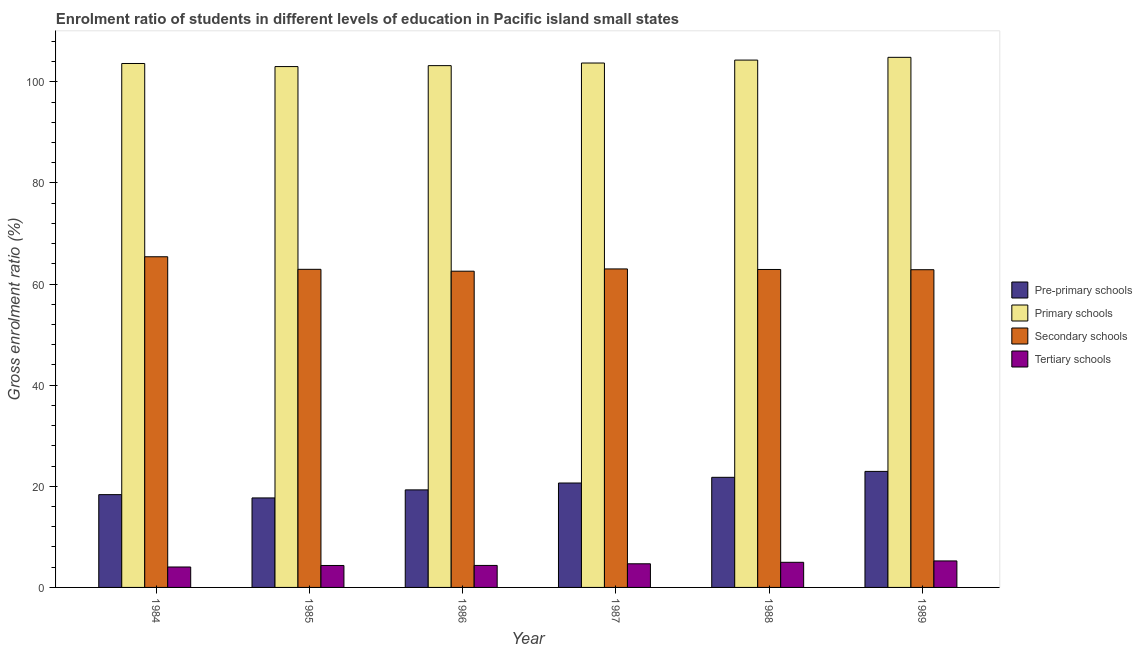How many different coloured bars are there?
Make the answer very short. 4. How many groups of bars are there?
Keep it short and to the point. 6. Are the number of bars per tick equal to the number of legend labels?
Offer a terse response. Yes. Are the number of bars on each tick of the X-axis equal?
Provide a succinct answer. Yes. How many bars are there on the 1st tick from the left?
Give a very brief answer. 4. How many bars are there on the 3rd tick from the right?
Provide a succinct answer. 4. What is the label of the 2nd group of bars from the left?
Offer a terse response. 1985. In how many cases, is the number of bars for a given year not equal to the number of legend labels?
Offer a terse response. 0. What is the gross enrolment ratio in secondary schools in 1988?
Your answer should be compact. 62.89. Across all years, what is the maximum gross enrolment ratio in pre-primary schools?
Your response must be concise. 22.95. Across all years, what is the minimum gross enrolment ratio in tertiary schools?
Ensure brevity in your answer.  4.04. In which year was the gross enrolment ratio in primary schools minimum?
Your response must be concise. 1985. What is the total gross enrolment ratio in tertiary schools in the graph?
Provide a short and direct response. 27.62. What is the difference between the gross enrolment ratio in tertiary schools in 1984 and that in 1986?
Offer a very short reply. -0.31. What is the difference between the gross enrolment ratio in secondary schools in 1989 and the gross enrolment ratio in tertiary schools in 1987?
Your response must be concise. -0.16. What is the average gross enrolment ratio in tertiary schools per year?
Give a very brief answer. 4.6. In the year 1987, what is the difference between the gross enrolment ratio in pre-primary schools and gross enrolment ratio in tertiary schools?
Offer a terse response. 0. What is the ratio of the gross enrolment ratio in pre-primary schools in 1984 to that in 1989?
Your answer should be compact. 0.8. Is the difference between the gross enrolment ratio in primary schools in 1987 and 1988 greater than the difference between the gross enrolment ratio in tertiary schools in 1987 and 1988?
Make the answer very short. No. What is the difference between the highest and the second highest gross enrolment ratio in secondary schools?
Make the answer very short. 2.41. What is the difference between the highest and the lowest gross enrolment ratio in primary schools?
Your answer should be very brief. 1.83. In how many years, is the gross enrolment ratio in primary schools greater than the average gross enrolment ratio in primary schools taken over all years?
Ensure brevity in your answer.  2. Is the sum of the gross enrolment ratio in secondary schools in 1984 and 1987 greater than the maximum gross enrolment ratio in tertiary schools across all years?
Provide a succinct answer. Yes. Is it the case that in every year, the sum of the gross enrolment ratio in secondary schools and gross enrolment ratio in tertiary schools is greater than the sum of gross enrolment ratio in pre-primary schools and gross enrolment ratio in primary schools?
Make the answer very short. No. What does the 1st bar from the left in 1986 represents?
Ensure brevity in your answer.  Pre-primary schools. What does the 1st bar from the right in 1984 represents?
Ensure brevity in your answer.  Tertiary schools. How many bars are there?
Your answer should be very brief. 24. Are the values on the major ticks of Y-axis written in scientific E-notation?
Keep it short and to the point. No. Does the graph contain grids?
Offer a very short reply. No. How many legend labels are there?
Give a very brief answer. 4. What is the title of the graph?
Make the answer very short. Enrolment ratio of students in different levels of education in Pacific island small states. What is the label or title of the X-axis?
Ensure brevity in your answer.  Year. What is the label or title of the Y-axis?
Your answer should be very brief. Gross enrolment ratio (%). What is the Gross enrolment ratio (%) in Pre-primary schools in 1984?
Ensure brevity in your answer.  18.35. What is the Gross enrolment ratio (%) in Primary schools in 1984?
Give a very brief answer. 103.63. What is the Gross enrolment ratio (%) in Secondary schools in 1984?
Your response must be concise. 65.4. What is the Gross enrolment ratio (%) in Tertiary schools in 1984?
Keep it short and to the point. 4.04. What is the Gross enrolment ratio (%) in Pre-primary schools in 1985?
Ensure brevity in your answer.  17.7. What is the Gross enrolment ratio (%) in Primary schools in 1985?
Provide a short and direct response. 103.02. What is the Gross enrolment ratio (%) of Secondary schools in 1985?
Make the answer very short. 62.92. What is the Gross enrolment ratio (%) of Tertiary schools in 1985?
Offer a very short reply. 4.34. What is the Gross enrolment ratio (%) in Pre-primary schools in 1986?
Your response must be concise. 19.29. What is the Gross enrolment ratio (%) of Primary schools in 1986?
Your response must be concise. 103.21. What is the Gross enrolment ratio (%) in Secondary schools in 1986?
Provide a succinct answer. 62.55. What is the Gross enrolment ratio (%) in Tertiary schools in 1986?
Provide a short and direct response. 4.35. What is the Gross enrolment ratio (%) in Pre-primary schools in 1987?
Provide a succinct answer. 20.65. What is the Gross enrolment ratio (%) in Primary schools in 1987?
Ensure brevity in your answer.  103.72. What is the Gross enrolment ratio (%) of Secondary schools in 1987?
Keep it short and to the point. 63. What is the Gross enrolment ratio (%) in Tertiary schools in 1987?
Provide a short and direct response. 4.67. What is the Gross enrolment ratio (%) in Pre-primary schools in 1988?
Provide a short and direct response. 21.78. What is the Gross enrolment ratio (%) in Primary schools in 1988?
Provide a short and direct response. 104.3. What is the Gross enrolment ratio (%) in Secondary schools in 1988?
Give a very brief answer. 62.89. What is the Gross enrolment ratio (%) of Tertiary schools in 1988?
Ensure brevity in your answer.  4.97. What is the Gross enrolment ratio (%) in Pre-primary schools in 1989?
Offer a very short reply. 22.95. What is the Gross enrolment ratio (%) of Primary schools in 1989?
Provide a short and direct response. 104.85. What is the Gross enrolment ratio (%) in Secondary schools in 1989?
Your answer should be compact. 62.84. What is the Gross enrolment ratio (%) of Tertiary schools in 1989?
Make the answer very short. 5.24. Across all years, what is the maximum Gross enrolment ratio (%) in Pre-primary schools?
Ensure brevity in your answer.  22.95. Across all years, what is the maximum Gross enrolment ratio (%) in Primary schools?
Give a very brief answer. 104.85. Across all years, what is the maximum Gross enrolment ratio (%) of Secondary schools?
Offer a terse response. 65.4. Across all years, what is the maximum Gross enrolment ratio (%) of Tertiary schools?
Your answer should be very brief. 5.24. Across all years, what is the minimum Gross enrolment ratio (%) of Pre-primary schools?
Keep it short and to the point. 17.7. Across all years, what is the minimum Gross enrolment ratio (%) of Primary schools?
Keep it short and to the point. 103.02. Across all years, what is the minimum Gross enrolment ratio (%) in Secondary schools?
Keep it short and to the point. 62.55. Across all years, what is the minimum Gross enrolment ratio (%) of Tertiary schools?
Keep it short and to the point. 4.04. What is the total Gross enrolment ratio (%) in Pre-primary schools in the graph?
Provide a succinct answer. 120.73. What is the total Gross enrolment ratio (%) of Primary schools in the graph?
Ensure brevity in your answer.  622.73. What is the total Gross enrolment ratio (%) in Secondary schools in the graph?
Ensure brevity in your answer.  379.59. What is the total Gross enrolment ratio (%) in Tertiary schools in the graph?
Ensure brevity in your answer.  27.62. What is the difference between the Gross enrolment ratio (%) in Pre-primary schools in 1984 and that in 1985?
Provide a succinct answer. 0.65. What is the difference between the Gross enrolment ratio (%) of Primary schools in 1984 and that in 1985?
Offer a terse response. 0.61. What is the difference between the Gross enrolment ratio (%) in Secondary schools in 1984 and that in 1985?
Offer a terse response. 2.48. What is the difference between the Gross enrolment ratio (%) in Tertiary schools in 1984 and that in 1985?
Provide a succinct answer. -0.3. What is the difference between the Gross enrolment ratio (%) of Pre-primary schools in 1984 and that in 1986?
Provide a succinct answer. -0.94. What is the difference between the Gross enrolment ratio (%) in Primary schools in 1984 and that in 1986?
Your answer should be very brief. 0.42. What is the difference between the Gross enrolment ratio (%) of Secondary schools in 1984 and that in 1986?
Your response must be concise. 2.85. What is the difference between the Gross enrolment ratio (%) in Tertiary schools in 1984 and that in 1986?
Ensure brevity in your answer.  -0.31. What is the difference between the Gross enrolment ratio (%) in Pre-primary schools in 1984 and that in 1987?
Your answer should be very brief. -2.3. What is the difference between the Gross enrolment ratio (%) in Primary schools in 1984 and that in 1987?
Your answer should be very brief. -0.09. What is the difference between the Gross enrolment ratio (%) in Secondary schools in 1984 and that in 1987?
Give a very brief answer. 2.41. What is the difference between the Gross enrolment ratio (%) in Tertiary schools in 1984 and that in 1987?
Provide a short and direct response. -0.63. What is the difference between the Gross enrolment ratio (%) of Pre-primary schools in 1984 and that in 1988?
Offer a terse response. -3.43. What is the difference between the Gross enrolment ratio (%) in Primary schools in 1984 and that in 1988?
Keep it short and to the point. -0.67. What is the difference between the Gross enrolment ratio (%) of Secondary schools in 1984 and that in 1988?
Your response must be concise. 2.52. What is the difference between the Gross enrolment ratio (%) in Tertiary schools in 1984 and that in 1988?
Give a very brief answer. -0.93. What is the difference between the Gross enrolment ratio (%) in Pre-primary schools in 1984 and that in 1989?
Keep it short and to the point. -4.59. What is the difference between the Gross enrolment ratio (%) in Primary schools in 1984 and that in 1989?
Offer a very short reply. -1.22. What is the difference between the Gross enrolment ratio (%) in Secondary schools in 1984 and that in 1989?
Give a very brief answer. 2.56. What is the difference between the Gross enrolment ratio (%) of Tertiary schools in 1984 and that in 1989?
Provide a succinct answer. -1.2. What is the difference between the Gross enrolment ratio (%) of Pre-primary schools in 1985 and that in 1986?
Offer a very short reply. -1.59. What is the difference between the Gross enrolment ratio (%) of Primary schools in 1985 and that in 1986?
Make the answer very short. -0.19. What is the difference between the Gross enrolment ratio (%) of Secondary schools in 1985 and that in 1986?
Offer a very short reply. 0.37. What is the difference between the Gross enrolment ratio (%) of Tertiary schools in 1985 and that in 1986?
Your response must be concise. -0.01. What is the difference between the Gross enrolment ratio (%) in Pre-primary schools in 1985 and that in 1987?
Make the answer very short. -2.95. What is the difference between the Gross enrolment ratio (%) of Primary schools in 1985 and that in 1987?
Make the answer very short. -0.7. What is the difference between the Gross enrolment ratio (%) of Secondary schools in 1985 and that in 1987?
Give a very brief answer. -0.08. What is the difference between the Gross enrolment ratio (%) in Tertiary schools in 1985 and that in 1987?
Your answer should be very brief. -0.33. What is the difference between the Gross enrolment ratio (%) in Pre-primary schools in 1985 and that in 1988?
Ensure brevity in your answer.  -4.08. What is the difference between the Gross enrolment ratio (%) in Primary schools in 1985 and that in 1988?
Your response must be concise. -1.28. What is the difference between the Gross enrolment ratio (%) in Secondary schools in 1985 and that in 1988?
Provide a short and direct response. 0.03. What is the difference between the Gross enrolment ratio (%) in Tertiary schools in 1985 and that in 1988?
Make the answer very short. -0.63. What is the difference between the Gross enrolment ratio (%) of Pre-primary schools in 1985 and that in 1989?
Keep it short and to the point. -5.25. What is the difference between the Gross enrolment ratio (%) of Primary schools in 1985 and that in 1989?
Your response must be concise. -1.83. What is the difference between the Gross enrolment ratio (%) of Secondary schools in 1985 and that in 1989?
Make the answer very short. 0.08. What is the difference between the Gross enrolment ratio (%) in Tertiary schools in 1985 and that in 1989?
Your response must be concise. -0.9. What is the difference between the Gross enrolment ratio (%) in Pre-primary schools in 1986 and that in 1987?
Your response must be concise. -1.36. What is the difference between the Gross enrolment ratio (%) in Primary schools in 1986 and that in 1987?
Keep it short and to the point. -0.52. What is the difference between the Gross enrolment ratio (%) of Secondary schools in 1986 and that in 1987?
Your response must be concise. -0.45. What is the difference between the Gross enrolment ratio (%) in Tertiary schools in 1986 and that in 1987?
Make the answer very short. -0.32. What is the difference between the Gross enrolment ratio (%) of Pre-primary schools in 1986 and that in 1988?
Your answer should be compact. -2.49. What is the difference between the Gross enrolment ratio (%) in Primary schools in 1986 and that in 1988?
Your answer should be very brief. -1.1. What is the difference between the Gross enrolment ratio (%) of Secondary schools in 1986 and that in 1988?
Offer a terse response. -0.34. What is the difference between the Gross enrolment ratio (%) in Tertiary schools in 1986 and that in 1988?
Your answer should be compact. -0.62. What is the difference between the Gross enrolment ratio (%) in Pre-primary schools in 1986 and that in 1989?
Provide a succinct answer. -3.66. What is the difference between the Gross enrolment ratio (%) of Primary schools in 1986 and that in 1989?
Give a very brief answer. -1.64. What is the difference between the Gross enrolment ratio (%) of Secondary schools in 1986 and that in 1989?
Provide a short and direct response. -0.29. What is the difference between the Gross enrolment ratio (%) in Tertiary schools in 1986 and that in 1989?
Your answer should be compact. -0.89. What is the difference between the Gross enrolment ratio (%) of Pre-primary schools in 1987 and that in 1988?
Keep it short and to the point. -1.13. What is the difference between the Gross enrolment ratio (%) of Primary schools in 1987 and that in 1988?
Keep it short and to the point. -0.58. What is the difference between the Gross enrolment ratio (%) in Secondary schools in 1987 and that in 1988?
Give a very brief answer. 0.11. What is the difference between the Gross enrolment ratio (%) of Tertiary schools in 1987 and that in 1988?
Your response must be concise. -0.3. What is the difference between the Gross enrolment ratio (%) of Pre-primary schools in 1987 and that in 1989?
Offer a very short reply. -2.3. What is the difference between the Gross enrolment ratio (%) in Primary schools in 1987 and that in 1989?
Your answer should be very brief. -1.13. What is the difference between the Gross enrolment ratio (%) of Secondary schools in 1987 and that in 1989?
Give a very brief answer. 0.16. What is the difference between the Gross enrolment ratio (%) in Tertiary schools in 1987 and that in 1989?
Your response must be concise. -0.57. What is the difference between the Gross enrolment ratio (%) of Pre-primary schools in 1988 and that in 1989?
Your answer should be compact. -1.17. What is the difference between the Gross enrolment ratio (%) in Primary schools in 1988 and that in 1989?
Your response must be concise. -0.55. What is the difference between the Gross enrolment ratio (%) of Secondary schools in 1988 and that in 1989?
Provide a short and direct response. 0.05. What is the difference between the Gross enrolment ratio (%) in Tertiary schools in 1988 and that in 1989?
Give a very brief answer. -0.27. What is the difference between the Gross enrolment ratio (%) of Pre-primary schools in 1984 and the Gross enrolment ratio (%) of Primary schools in 1985?
Make the answer very short. -84.67. What is the difference between the Gross enrolment ratio (%) in Pre-primary schools in 1984 and the Gross enrolment ratio (%) in Secondary schools in 1985?
Your answer should be compact. -44.57. What is the difference between the Gross enrolment ratio (%) of Pre-primary schools in 1984 and the Gross enrolment ratio (%) of Tertiary schools in 1985?
Provide a short and direct response. 14.01. What is the difference between the Gross enrolment ratio (%) of Primary schools in 1984 and the Gross enrolment ratio (%) of Secondary schools in 1985?
Give a very brief answer. 40.71. What is the difference between the Gross enrolment ratio (%) in Primary schools in 1984 and the Gross enrolment ratio (%) in Tertiary schools in 1985?
Offer a very short reply. 99.29. What is the difference between the Gross enrolment ratio (%) of Secondary schools in 1984 and the Gross enrolment ratio (%) of Tertiary schools in 1985?
Your answer should be compact. 61.06. What is the difference between the Gross enrolment ratio (%) in Pre-primary schools in 1984 and the Gross enrolment ratio (%) in Primary schools in 1986?
Your answer should be very brief. -84.85. What is the difference between the Gross enrolment ratio (%) in Pre-primary schools in 1984 and the Gross enrolment ratio (%) in Secondary schools in 1986?
Your answer should be very brief. -44.2. What is the difference between the Gross enrolment ratio (%) of Pre-primary schools in 1984 and the Gross enrolment ratio (%) of Tertiary schools in 1986?
Ensure brevity in your answer.  14. What is the difference between the Gross enrolment ratio (%) in Primary schools in 1984 and the Gross enrolment ratio (%) in Secondary schools in 1986?
Your answer should be compact. 41.08. What is the difference between the Gross enrolment ratio (%) of Primary schools in 1984 and the Gross enrolment ratio (%) of Tertiary schools in 1986?
Offer a very short reply. 99.28. What is the difference between the Gross enrolment ratio (%) in Secondary schools in 1984 and the Gross enrolment ratio (%) in Tertiary schools in 1986?
Your answer should be compact. 61.05. What is the difference between the Gross enrolment ratio (%) in Pre-primary schools in 1984 and the Gross enrolment ratio (%) in Primary schools in 1987?
Offer a terse response. -85.37. What is the difference between the Gross enrolment ratio (%) of Pre-primary schools in 1984 and the Gross enrolment ratio (%) of Secondary schools in 1987?
Make the answer very short. -44.64. What is the difference between the Gross enrolment ratio (%) of Pre-primary schools in 1984 and the Gross enrolment ratio (%) of Tertiary schools in 1987?
Provide a succinct answer. 13.68. What is the difference between the Gross enrolment ratio (%) in Primary schools in 1984 and the Gross enrolment ratio (%) in Secondary schools in 1987?
Offer a very short reply. 40.63. What is the difference between the Gross enrolment ratio (%) of Primary schools in 1984 and the Gross enrolment ratio (%) of Tertiary schools in 1987?
Provide a succinct answer. 98.96. What is the difference between the Gross enrolment ratio (%) in Secondary schools in 1984 and the Gross enrolment ratio (%) in Tertiary schools in 1987?
Offer a terse response. 60.73. What is the difference between the Gross enrolment ratio (%) in Pre-primary schools in 1984 and the Gross enrolment ratio (%) in Primary schools in 1988?
Offer a terse response. -85.95. What is the difference between the Gross enrolment ratio (%) of Pre-primary schools in 1984 and the Gross enrolment ratio (%) of Secondary schools in 1988?
Ensure brevity in your answer.  -44.53. What is the difference between the Gross enrolment ratio (%) of Pre-primary schools in 1984 and the Gross enrolment ratio (%) of Tertiary schools in 1988?
Provide a succinct answer. 13.38. What is the difference between the Gross enrolment ratio (%) of Primary schools in 1984 and the Gross enrolment ratio (%) of Secondary schools in 1988?
Make the answer very short. 40.74. What is the difference between the Gross enrolment ratio (%) of Primary schools in 1984 and the Gross enrolment ratio (%) of Tertiary schools in 1988?
Offer a very short reply. 98.66. What is the difference between the Gross enrolment ratio (%) of Secondary schools in 1984 and the Gross enrolment ratio (%) of Tertiary schools in 1988?
Provide a short and direct response. 60.43. What is the difference between the Gross enrolment ratio (%) in Pre-primary schools in 1984 and the Gross enrolment ratio (%) in Primary schools in 1989?
Give a very brief answer. -86.5. What is the difference between the Gross enrolment ratio (%) in Pre-primary schools in 1984 and the Gross enrolment ratio (%) in Secondary schools in 1989?
Make the answer very short. -44.49. What is the difference between the Gross enrolment ratio (%) of Pre-primary schools in 1984 and the Gross enrolment ratio (%) of Tertiary schools in 1989?
Make the answer very short. 13.11. What is the difference between the Gross enrolment ratio (%) in Primary schools in 1984 and the Gross enrolment ratio (%) in Secondary schools in 1989?
Make the answer very short. 40.79. What is the difference between the Gross enrolment ratio (%) of Primary schools in 1984 and the Gross enrolment ratio (%) of Tertiary schools in 1989?
Provide a short and direct response. 98.39. What is the difference between the Gross enrolment ratio (%) in Secondary schools in 1984 and the Gross enrolment ratio (%) in Tertiary schools in 1989?
Make the answer very short. 60.16. What is the difference between the Gross enrolment ratio (%) in Pre-primary schools in 1985 and the Gross enrolment ratio (%) in Primary schools in 1986?
Provide a short and direct response. -85.5. What is the difference between the Gross enrolment ratio (%) in Pre-primary schools in 1985 and the Gross enrolment ratio (%) in Secondary schools in 1986?
Offer a terse response. -44.85. What is the difference between the Gross enrolment ratio (%) in Pre-primary schools in 1985 and the Gross enrolment ratio (%) in Tertiary schools in 1986?
Offer a terse response. 13.35. What is the difference between the Gross enrolment ratio (%) in Primary schools in 1985 and the Gross enrolment ratio (%) in Secondary schools in 1986?
Your answer should be compact. 40.47. What is the difference between the Gross enrolment ratio (%) of Primary schools in 1985 and the Gross enrolment ratio (%) of Tertiary schools in 1986?
Offer a very short reply. 98.67. What is the difference between the Gross enrolment ratio (%) of Secondary schools in 1985 and the Gross enrolment ratio (%) of Tertiary schools in 1986?
Provide a short and direct response. 58.57. What is the difference between the Gross enrolment ratio (%) in Pre-primary schools in 1985 and the Gross enrolment ratio (%) in Primary schools in 1987?
Your answer should be compact. -86.02. What is the difference between the Gross enrolment ratio (%) in Pre-primary schools in 1985 and the Gross enrolment ratio (%) in Secondary schools in 1987?
Your response must be concise. -45.29. What is the difference between the Gross enrolment ratio (%) of Pre-primary schools in 1985 and the Gross enrolment ratio (%) of Tertiary schools in 1987?
Your answer should be very brief. 13.03. What is the difference between the Gross enrolment ratio (%) of Primary schools in 1985 and the Gross enrolment ratio (%) of Secondary schools in 1987?
Your response must be concise. 40.02. What is the difference between the Gross enrolment ratio (%) in Primary schools in 1985 and the Gross enrolment ratio (%) in Tertiary schools in 1987?
Offer a very short reply. 98.35. What is the difference between the Gross enrolment ratio (%) of Secondary schools in 1985 and the Gross enrolment ratio (%) of Tertiary schools in 1987?
Your response must be concise. 58.25. What is the difference between the Gross enrolment ratio (%) in Pre-primary schools in 1985 and the Gross enrolment ratio (%) in Primary schools in 1988?
Keep it short and to the point. -86.6. What is the difference between the Gross enrolment ratio (%) in Pre-primary schools in 1985 and the Gross enrolment ratio (%) in Secondary schools in 1988?
Provide a short and direct response. -45.18. What is the difference between the Gross enrolment ratio (%) of Pre-primary schools in 1985 and the Gross enrolment ratio (%) of Tertiary schools in 1988?
Provide a succinct answer. 12.73. What is the difference between the Gross enrolment ratio (%) in Primary schools in 1985 and the Gross enrolment ratio (%) in Secondary schools in 1988?
Provide a succinct answer. 40.13. What is the difference between the Gross enrolment ratio (%) of Primary schools in 1985 and the Gross enrolment ratio (%) of Tertiary schools in 1988?
Offer a very short reply. 98.05. What is the difference between the Gross enrolment ratio (%) of Secondary schools in 1985 and the Gross enrolment ratio (%) of Tertiary schools in 1988?
Your answer should be compact. 57.95. What is the difference between the Gross enrolment ratio (%) of Pre-primary schools in 1985 and the Gross enrolment ratio (%) of Primary schools in 1989?
Provide a short and direct response. -87.15. What is the difference between the Gross enrolment ratio (%) of Pre-primary schools in 1985 and the Gross enrolment ratio (%) of Secondary schools in 1989?
Offer a very short reply. -45.14. What is the difference between the Gross enrolment ratio (%) of Pre-primary schools in 1985 and the Gross enrolment ratio (%) of Tertiary schools in 1989?
Keep it short and to the point. 12.46. What is the difference between the Gross enrolment ratio (%) of Primary schools in 1985 and the Gross enrolment ratio (%) of Secondary schools in 1989?
Your response must be concise. 40.18. What is the difference between the Gross enrolment ratio (%) in Primary schools in 1985 and the Gross enrolment ratio (%) in Tertiary schools in 1989?
Offer a very short reply. 97.78. What is the difference between the Gross enrolment ratio (%) of Secondary schools in 1985 and the Gross enrolment ratio (%) of Tertiary schools in 1989?
Provide a succinct answer. 57.68. What is the difference between the Gross enrolment ratio (%) in Pre-primary schools in 1986 and the Gross enrolment ratio (%) in Primary schools in 1987?
Your answer should be very brief. -84.43. What is the difference between the Gross enrolment ratio (%) in Pre-primary schools in 1986 and the Gross enrolment ratio (%) in Secondary schools in 1987?
Give a very brief answer. -43.7. What is the difference between the Gross enrolment ratio (%) in Pre-primary schools in 1986 and the Gross enrolment ratio (%) in Tertiary schools in 1987?
Offer a very short reply. 14.62. What is the difference between the Gross enrolment ratio (%) in Primary schools in 1986 and the Gross enrolment ratio (%) in Secondary schools in 1987?
Offer a very short reply. 40.21. What is the difference between the Gross enrolment ratio (%) in Primary schools in 1986 and the Gross enrolment ratio (%) in Tertiary schools in 1987?
Provide a short and direct response. 98.53. What is the difference between the Gross enrolment ratio (%) of Secondary schools in 1986 and the Gross enrolment ratio (%) of Tertiary schools in 1987?
Offer a very short reply. 57.87. What is the difference between the Gross enrolment ratio (%) of Pre-primary schools in 1986 and the Gross enrolment ratio (%) of Primary schools in 1988?
Your answer should be compact. -85.01. What is the difference between the Gross enrolment ratio (%) in Pre-primary schools in 1986 and the Gross enrolment ratio (%) in Secondary schools in 1988?
Offer a terse response. -43.59. What is the difference between the Gross enrolment ratio (%) of Pre-primary schools in 1986 and the Gross enrolment ratio (%) of Tertiary schools in 1988?
Provide a succinct answer. 14.32. What is the difference between the Gross enrolment ratio (%) of Primary schools in 1986 and the Gross enrolment ratio (%) of Secondary schools in 1988?
Provide a short and direct response. 40.32. What is the difference between the Gross enrolment ratio (%) in Primary schools in 1986 and the Gross enrolment ratio (%) in Tertiary schools in 1988?
Keep it short and to the point. 98.24. What is the difference between the Gross enrolment ratio (%) of Secondary schools in 1986 and the Gross enrolment ratio (%) of Tertiary schools in 1988?
Provide a succinct answer. 57.58. What is the difference between the Gross enrolment ratio (%) in Pre-primary schools in 1986 and the Gross enrolment ratio (%) in Primary schools in 1989?
Ensure brevity in your answer.  -85.56. What is the difference between the Gross enrolment ratio (%) in Pre-primary schools in 1986 and the Gross enrolment ratio (%) in Secondary schools in 1989?
Offer a terse response. -43.55. What is the difference between the Gross enrolment ratio (%) of Pre-primary schools in 1986 and the Gross enrolment ratio (%) of Tertiary schools in 1989?
Offer a terse response. 14.05. What is the difference between the Gross enrolment ratio (%) of Primary schools in 1986 and the Gross enrolment ratio (%) of Secondary schools in 1989?
Provide a succinct answer. 40.37. What is the difference between the Gross enrolment ratio (%) of Primary schools in 1986 and the Gross enrolment ratio (%) of Tertiary schools in 1989?
Your answer should be compact. 97.97. What is the difference between the Gross enrolment ratio (%) in Secondary schools in 1986 and the Gross enrolment ratio (%) in Tertiary schools in 1989?
Your answer should be very brief. 57.31. What is the difference between the Gross enrolment ratio (%) of Pre-primary schools in 1987 and the Gross enrolment ratio (%) of Primary schools in 1988?
Your response must be concise. -83.65. What is the difference between the Gross enrolment ratio (%) of Pre-primary schools in 1987 and the Gross enrolment ratio (%) of Secondary schools in 1988?
Offer a very short reply. -42.23. What is the difference between the Gross enrolment ratio (%) in Pre-primary schools in 1987 and the Gross enrolment ratio (%) in Tertiary schools in 1988?
Provide a succinct answer. 15.68. What is the difference between the Gross enrolment ratio (%) of Primary schools in 1987 and the Gross enrolment ratio (%) of Secondary schools in 1988?
Keep it short and to the point. 40.84. What is the difference between the Gross enrolment ratio (%) in Primary schools in 1987 and the Gross enrolment ratio (%) in Tertiary schools in 1988?
Make the answer very short. 98.75. What is the difference between the Gross enrolment ratio (%) of Secondary schools in 1987 and the Gross enrolment ratio (%) of Tertiary schools in 1988?
Your response must be concise. 58.03. What is the difference between the Gross enrolment ratio (%) in Pre-primary schools in 1987 and the Gross enrolment ratio (%) in Primary schools in 1989?
Ensure brevity in your answer.  -84.2. What is the difference between the Gross enrolment ratio (%) of Pre-primary schools in 1987 and the Gross enrolment ratio (%) of Secondary schools in 1989?
Ensure brevity in your answer.  -42.19. What is the difference between the Gross enrolment ratio (%) of Pre-primary schools in 1987 and the Gross enrolment ratio (%) of Tertiary schools in 1989?
Your answer should be compact. 15.41. What is the difference between the Gross enrolment ratio (%) in Primary schools in 1987 and the Gross enrolment ratio (%) in Secondary schools in 1989?
Give a very brief answer. 40.88. What is the difference between the Gross enrolment ratio (%) in Primary schools in 1987 and the Gross enrolment ratio (%) in Tertiary schools in 1989?
Ensure brevity in your answer.  98.48. What is the difference between the Gross enrolment ratio (%) of Secondary schools in 1987 and the Gross enrolment ratio (%) of Tertiary schools in 1989?
Make the answer very short. 57.76. What is the difference between the Gross enrolment ratio (%) of Pre-primary schools in 1988 and the Gross enrolment ratio (%) of Primary schools in 1989?
Offer a very short reply. -83.07. What is the difference between the Gross enrolment ratio (%) in Pre-primary schools in 1988 and the Gross enrolment ratio (%) in Secondary schools in 1989?
Make the answer very short. -41.06. What is the difference between the Gross enrolment ratio (%) of Pre-primary schools in 1988 and the Gross enrolment ratio (%) of Tertiary schools in 1989?
Keep it short and to the point. 16.54. What is the difference between the Gross enrolment ratio (%) in Primary schools in 1988 and the Gross enrolment ratio (%) in Secondary schools in 1989?
Your response must be concise. 41.46. What is the difference between the Gross enrolment ratio (%) of Primary schools in 1988 and the Gross enrolment ratio (%) of Tertiary schools in 1989?
Offer a terse response. 99.06. What is the difference between the Gross enrolment ratio (%) of Secondary schools in 1988 and the Gross enrolment ratio (%) of Tertiary schools in 1989?
Ensure brevity in your answer.  57.65. What is the average Gross enrolment ratio (%) in Pre-primary schools per year?
Your answer should be very brief. 20.12. What is the average Gross enrolment ratio (%) of Primary schools per year?
Ensure brevity in your answer.  103.79. What is the average Gross enrolment ratio (%) in Secondary schools per year?
Give a very brief answer. 63.27. What is the average Gross enrolment ratio (%) in Tertiary schools per year?
Your answer should be compact. 4.6. In the year 1984, what is the difference between the Gross enrolment ratio (%) in Pre-primary schools and Gross enrolment ratio (%) in Primary schools?
Provide a succinct answer. -85.28. In the year 1984, what is the difference between the Gross enrolment ratio (%) of Pre-primary schools and Gross enrolment ratio (%) of Secondary schools?
Ensure brevity in your answer.  -47.05. In the year 1984, what is the difference between the Gross enrolment ratio (%) of Pre-primary schools and Gross enrolment ratio (%) of Tertiary schools?
Provide a short and direct response. 14.31. In the year 1984, what is the difference between the Gross enrolment ratio (%) in Primary schools and Gross enrolment ratio (%) in Secondary schools?
Keep it short and to the point. 38.23. In the year 1984, what is the difference between the Gross enrolment ratio (%) in Primary schools and Gross enrolment ratio (%) in Tertiary schools?
Offer a very short reply. 99.59. In the year 1984, what is the difference between the Gross enrolment ratio (%) in Secondary schools and Gross enrolment ratio (%) in Tertiary schools?
Provide a short and direct response. 61.36. In the year 1985, what is the difference between the Gross enrolment ratio (%) of Pre-primary schools and Gross enrolment ratio (%) of Primary schools?
Ensure brevity in your answer.  -85.32. In the year 1985, what is the difference between the Gross enrolment ratio (%) of Pre-primary schools and Gross enrolment ratio (%) of Secondary schools?
Your answer should be compact. -45.22. In the year 1985, what is the difference between the Gross enrolment ratio (%) of Pre-primary schools and Gross enrolment ratio (%) of Tertiary schools?
Keep it short and to the point. 13.36. In the year 1985, what is the difference between the Gross enrolment ratio (%) of Primary schools and Gross enrolment ratio (%) of Secondary schools?
Give a very brief answer. 40.1. In the year 1985, what is the difference between the Gross enrolment ratio (%) of Primary schools and Gross enrolment ratio (%) of Tertiary schools?
Give a very brief answer. 98.68. In the year 1985, what is the difference between the Gross enrolment ratio (%) in Secondary schools and Gross enrolment ratio (%) in Tertiary schools?
Your answer should be very brief. 58.58. In the year 1986, what is the difference between the Gross enrolment ratio (%) of Pre-primary schools and Gross enrolment ratio (%) of Primary schools?
Offer a very short reply. -83.91. In the year 1986, what is the difference between the Gross enrolment ratio (%) of Pre-primary schools and Gross enrolment ratio (%) of Secondary schools?
Offer a terse response. -43.26. In the year 1986, what is the difference between the Gross enrolment ratio (%) of Pre-primary schools and Gross enrolment ratio (%) of Tertiary schools?
Offer a terse response. 14.94. In the year 1986, what is the difference between the Gross enrolment ratio (%) in Primary schools and Gross enrolment ratio (%) in Secondary schools?
Make the answer very short. 40.66. In the year 1986, what is the difference between the Gross enrolment ratio (%) in Primary schools and Gross enrolment ratio (%) in Tertiary schools?
Give a very brief answer. 98.86. In the year 1986, what is the difference between the Gross enrolment ratio (%) of Secondary schools and Gross enrolment ratio (%) of Tertiary schools?
Make the answer very short. 58.2. In the year 1987, what is the difference between the Gross enrolment ratio (%) of Pre-primary schools and Gross enrolment ratio (%) of Primary schools?
Provide a short and direct response. -83.07. In the year 1987, what is the difference between the Gross enrolment ratio (%) in Pre-primary schools and Gross enrolment ratio (%) in Secondary schools?
Keep it short and to the point. -42.34. In the year 1987, what is the difference between the Gross enrolment ratio (%) in Pre-primary schools and Gross enrolment ratio (%) in Tertiary schools?
Keep it short and to the point. 15.98. In the year 1987, what is the difference between the Gross enrolment ratio (%) in Primary schools and Gross enrolment ratio (%) in Secondary schools?
Offer a very short reply. 40.73. In the year 1987, what is the difference between the Gross enrolment ratio (%) in Primary schools and Gross enrolment ratio (%) in Tertiary schools?
Provide a succinct answer. 99.05. In the year 1987, what is the difference between the Gross enrolment ratio (%) in Secondary schools and Gross enrolment ratio (%) in Tertiary schools?
Your answer should be very brief. 58.32. In the year 1988, what is the difference between the Gross enrolment ratio (%) in Pre-primary schools and Gross enrolment ratio (%) in Primary schools?
Your answer should be very brief. -82.52. In the year 1988, what is the difference between the Gross enrolment ratio (%) of Pre-primary schools and Gross enrolment ratio (%) of Secondary schools?
Your response must be concise. -41.11. In the year 1988, what is the difference between the Gross enrolment ratio (%) of Pre-primary schools and Gross enrolment ratio (%) of Tertiary schools?
Your answer should be compact. 16.81. In the year 1988, what is the difference between the Gross enrolment ratio (%) of Primary schools and Gross enrolment ratio (%) of Secondary schools?
Your response must be concise. 41.42. In the year 1988, what is the difference between the Gross enrolment ratio (%) in Primary schools and Gross enrolment ratio (%) in Tertiary schools?
Offer a terse response. 99.33. In the year 1988, what is the difference between the Gross enrolment ratio (%) in Secondary schools and Gross enrolment ratio (%) in Tertiary schools?
Your response must be concise. 57.92. In the year 1989, what is the difference between the Gross enrolment ratio (%) of Pre-primary schools and Gross enrolment ratio (%) of Primary schools?
Your answer should be compact. -81.9. In the year 1989, what is the difference between the Gross enrolment ratio (%) in Pre-primary schools and Gross enrolment ratio (%) in Secondary schools?
Keep it short and to the point. -39.89. In the year 1989, what is the difference between the Gross enrolment ratio (%) of Pre-primary schools and Gross enrolment ratio (%) of Tertiary schools?
Provide a succinct answer. 17.71. In the year 1989, what is the difference between the Gross enrolment ratio (%) of Primary schools and Gross enrolment ratio (%) of Secondary schools?
Ensure brevity in your answer.  42.01. In the year 1989, what is the difference between the Gross enrolment ratio (%) of Primary schools and Gross enrolment ratio (%) of Tertiary schools?
Your response must be concise. 99.61. In the year 1989, what is the difference between the Gross enrolment ratio (%) in Secondary schools and Gross enrolment ratio (%) in Tertiary schools?
Your answer should be compact. 57.6. What is the ratio of the Gross enrolment ratio (%) in Pre-primary schools in 1984 to that in 1985?
Make the answer very short. 1.04. What is the ratio of the Gross enrolment ratio (%) in Primary schools in 1984 to that in 1985?
Provide a succinct answer. 1.01. What is the ratio of the Gross enrolment ratio (%) of Secondary schools in 1984 to that in 1985?
Provide a succinct answer. 1.04. What is the ratio of the Gross enrolment ratio (%) in Tertiary schools in 1984 to that in 1985?
Give a very brief answer. 0.93. What is the ratio of the Gross enrolment ratio (%) of Pre-primary schools in 1984 to that in 1986?
Your answer should be compact. 0.95. What is the ratio of the Gross enrolment ratio (%) in Primary schools in 1984 to that in 1986?
Provide a short and direct response. 1. What is the ratio of the Gross enrolment ratio (%) in Secondary schools in 1984 to that in 1986?
Provide a succinct answer. 1.05. What is the ratio of the Gross enrolment ratio (%) of Tertiary schools in 1984 to that in 1986?
Your answer should be compact. 0.93. What is the ratio of the Gross enrolment ratio (%) in Pre-primary schools in 1984 to that in 1987?
Offer a terse response. 0.89. What is the ratio of the Gross enrolment ratio (%) in Secondary schools in 1984 to that in 1987?
Give a very brief answer. 1.04. What is the ratio of the Gross enrolment ratio (%) of Tertiary schools in 1984 to that in 1987?
Your answer should be very brief. 0.86. What is the ratio of the Gross enrolment ratio (%) of Pre-primary schools in 1984 to that in 1988?
Offer a terse response. 0.84. What is the ratio of the Gross enrolment ratio (%) of Tertiary schools in 1984 to that in 1988?
Provide a succinct answer. 0.81. What is the ratio of the Gross enrolment ratio (%) in Pre-primary schools in 1984 to that in 1989?
Make the answer very short. 0.8. What is the ratio of the Gross enrolment ratio (%) in Primary schools in 1984 to that in 1989?
Offer a terse response. 0.99. What is the ratio of the Gross enrolment ratio (%) of Secondary schools in 1984 to that in 1989?
Ensure brevity in your answer.  1.04. What is the ratio of the Gross enrolment ratio (%) in Tertiary schools in 1984 to that in 1989?
Provide a succinct answer. 0.77. What is the ratio of the Gross enrolment ratio (%) of Pre-primary schools in 1985 to that in 1986?
Your answer should be very brief. 0.92. What is the ratio of the Gross enrolment ratio (%) in Secondary schools in 1985 to that in 1986?
Provide a succinct answer. 1.01. What is the ratio of the Gross enrolment ratio (%) of Pre-primary schools in 1985 to that in 1987?
Your response must be concise. 0.86. What is the ratio of the Gross enrolment ratio (%) of Primary schools in 1985 to that in 1987?
Provide a succinct answer. 0.99. What is the ratio of the Gross enrolment ratio (%) of Tertiary schools in 1985 to that in 1987?
Give a very brief answer. 0.93. What is the ratio of the Gross enrolment ratio (%) in Pre-primary schools in 1985 to that in 1988?
Your answer should be very brief. 0.81. What is the ratio of the Gross enrolment ratio (%) in Primary schools in 1985 to that in 1988?
Give a very brief answer. 0.99. What is the ratio of the Gross enrolment ratio (%) of Secondary schools in 1985 to that in 1988?
Make the answer very short. 1. What is the ratio of the Gross enrolment ratio (%) of Tertiary schools in 1985 to that in 1988?
Keep it short and to the point. 0.87. What is the ratio of the Gross enrolment ratio (%) in Pre-primary schools in 1985 to that in 1989?
Give a very brief answer. 0.77. What is the ratio of the Gross enrolment ratio (%) in Primary schools in 1985 to that in 1989?
Your answer should be compact. 0.98. What is the ratio of the Gross enrolment ratio (%) in Tertiary schools in 1985 to that in 1989?
Make the answer very short. 0.83. What is the ratio of the Gross enrolment ratio (%) of Pre-primary schools in 1986 to that in 1987?
Make the answer very short. 0.93. What is the ratio of the Gross enrolment ratio (%) of Secondary schools in 1986 to that in 1987?
Provide a succinct answer. 0.99. What is the ratio of the Gross enrolment ratio (%) of Tertiary schools in 1986 to that in 1987?
Your answer should be very brief. 0.93. What is the ratio of the Gross enrolment ratio (%) in Pre-primary schools in 1986 to that in 1988?
Your response must be concise. 0.89. What is the ratio of the Gross enrolment ratio (%) of Secondary schools in 1986 to that in 1988?
Keep it short and to the point. 0.99. What is the ratio of the Gross enrolment ratio (%) of Tertiary schools in 1986 to that in 1988?
Provide a short and direct response. 0.88. What is the ratio of the Gross enrolment ratio (%) of Pre-primary schools in 1986 to that in 1989?
Your response must be concise. 0.84. What is the ratio of the Gross enrolment ratio (%) of Primary schools in 1986 to that in 1989?
Provide a short and direct response. 0.98. What is the ratio of the Gross enrolment ratio (%) of Tertiary schools in 1986 to that in 1989?
Provide a short and direct response. 0.83. What is the ratio of the Gross enrolment ratio (%) of Pre-primary schools in 1987 to that in 1988?
Offer a very short reply. 0.95. What is the ratio of the Gross enrolment ratio (%) of Primary schools in 1987 to that in 1988?
Provide a succinct answer. 0.99. What is the ratio of the Gross enrolment ratio (%) in Secondary schools in 1987 to that in 1988?
Offer a terse response. 1. What is the ratio of the Gross enrolment ratio (%) in Tertiary schools in 1987 to that in 1988?
Offer a very short reply. 0.94. What is the ratio of the Gross enrolment ratio (%) in Pre-primary schools in 1987 to that in 1989?
Offer a very short reply. 0.9. What is the ratio of the Gross enrolment ratio (%) of Primary schools in 1987 to that in 1989?
Offer a very short reply. 0.99. What is the ratio of the Gross enrolment ratio (%) of Tertiary schools in 1987 to that in 1989?
Give a very brief answer. 0.89. What is the ratio of the Gross enrolment ratio (%) of Pre-primary schools in 1988 to that in 1989?
Your answer should be very brief. 0.95. What is the ratio of the Gross enrolment ratio (%) of Primary schools in 1988 to that in 1989?
Provide a short and direct response. 0.99. What is the ratio of the Gross enrolment ratio (%) of Tertiary schools in 1988 to that in 1989?
Offer a terse response. 0.95. What is the difference between the highest and the second highest Gross enrolment ratio (%) in Pre-primary schools?
Your answer should be very brief. 1.17. What is the difference between the highest and the second highest Gross enrolment ratio (%) in Primary schools?
Your answer should be compact. 0.55. What is the difference between the highest and the second highest Gross enrolment ratio (%) in Secondary schools?
Ensure brevity in your answer.  2.41. What is the difference between the highest and the second highest Gross enrolment ratio (%) of Tertiary schools?
Provide a short and direct response. 0.27. What is the difference between the highest and the lowest Gross enrolment ratio (%) in Pre-primary schools?
Make the answer very short. 5.25. What is the difference between the highest and the lowest Gross enrolment ratio (%) in Primary schools?
Give a very brief answer. 1.83. What is the difference between the highest and the lowest Gross enrolment ratio (%) in Secondary schools?
Your answer should be very brief. 2.85. What is the difference between the highest and the lowest Gross enrolment ratio (%) of Tertiary schools?
Ensure brevity in your answer.  1.2. 